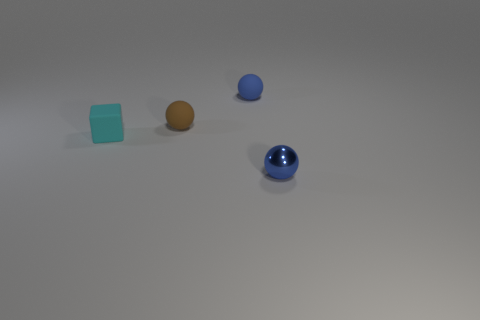Add 3 cyan cubes. How many objects exist? 7 Subtract all balls. How many objects are left? 1 Add 1 small matte cubes. How many small matte cubes are left? 2 Add 2 spheres. How many spheres exist? 5 Subtract 0 green balls. How many objects are left? 4 Subtract all red metallic blocks. Subtract all small rubber spheres. How many objects are left? 2 